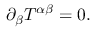<formula> <loc_0><loc_0><loc_500><loc_500>\begin{array} { r } { \partial _ { \beta } T ^ { \alpha \beta } = 0 . } \end{array}</formula> 